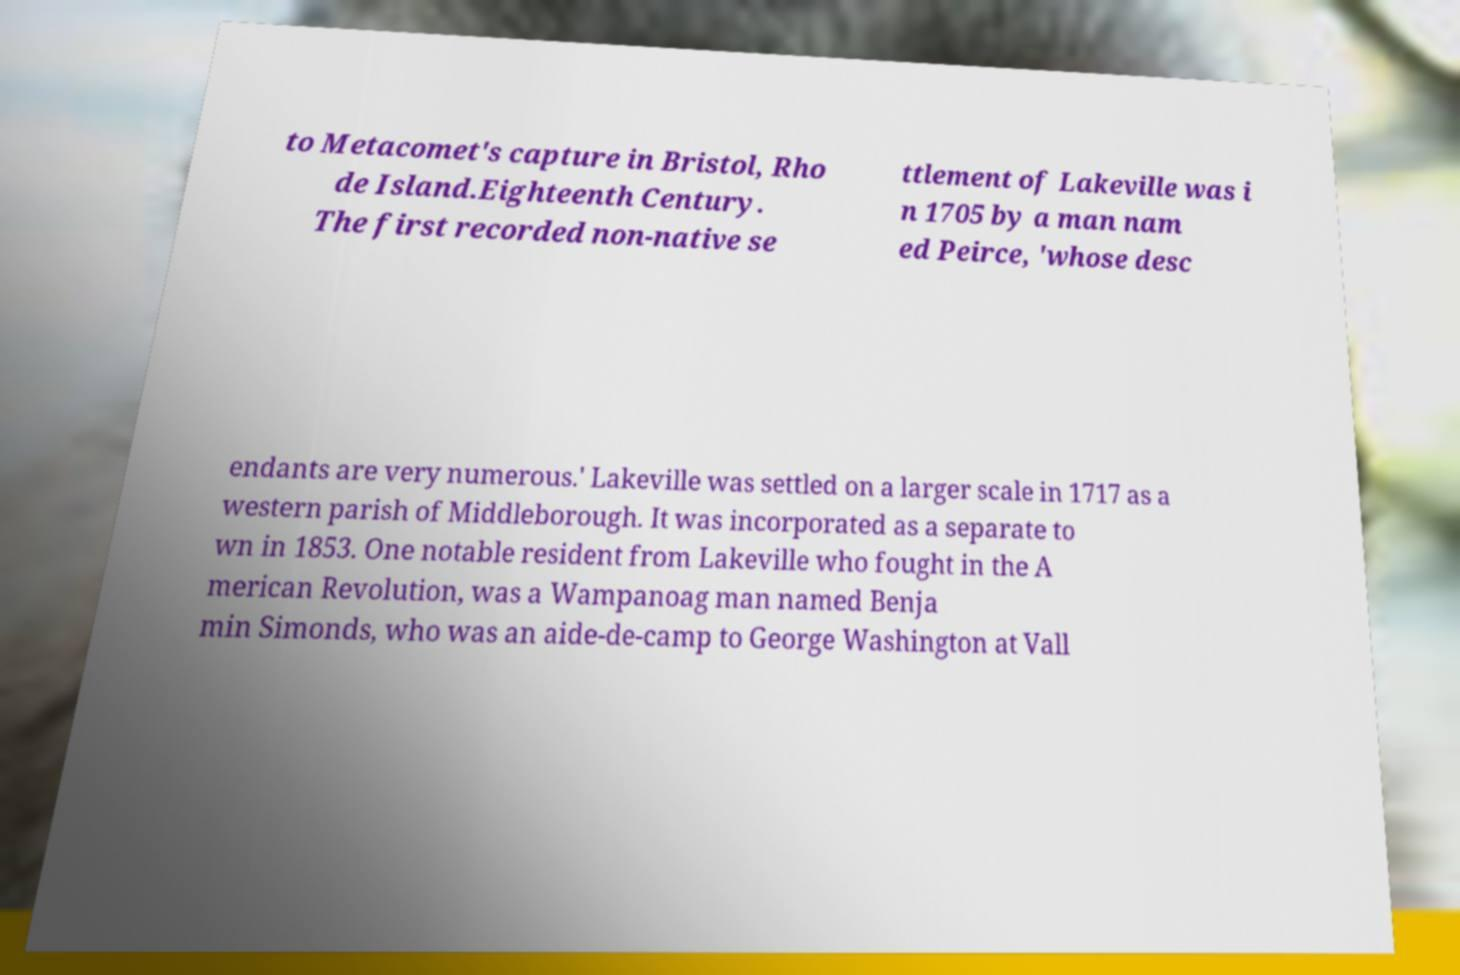Please read and relay the text visible in this image. What does it say? to Metacomet's capture in Bristol, Rho de Island.Eighteenth Century. The first recorded non-native se ttlement of Lakeville was i n 1705 by a man nam ed Peirce, 'whose desc endants are very numerous.' Lakeville was settled on a larger scale in 1717 as a western parish of Middleborough. It was incorporated as a separate to wn in 1853. One notable resident from Lakeville who fought in the A merican Revolution, was a Wampanoag man named Benja min Simonds, who was an aide-de-camp to George Washington at Vall 